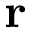<formula> <loc_0><loc_0><loc_500><loc_500>{ r }</formula> 